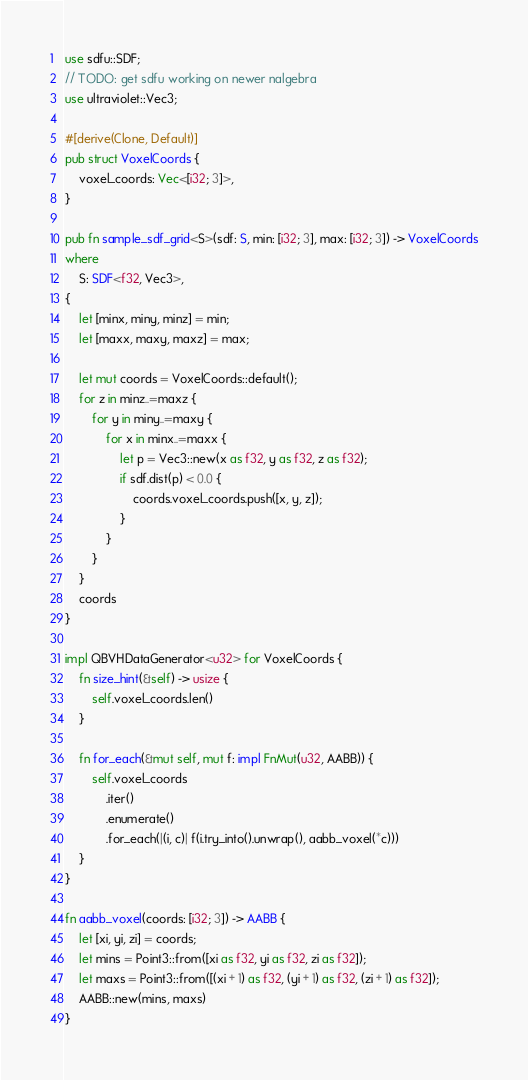<code> <loc_0><loc_0><loc_500><loc_500><_Rust_>use sdfu::SDF;
// TODO: get sdfu working on newer nalgebra
use ultraviolet::Vec3;

#[derive(Clone, Default)]
pub struct VoxelCoords {
    voxel_coords: Vec<[i32; 3]>,
}

pub fn sample_sdf_grid<S>(sdf: S, min: [i32; 3], max: [i32; 3]) -> VoxelCoords
where
    S: SDF<f32, Vec3>,
{
    let [minx, miny, minz] = min;
    let [maxx, maxy, maxz] = max;

    let mut coords = VoxelCoords::default();
    for z in minz..=maxz {
        for y in miny..=maxy {
            for x in minx..=maxx {
                let p = Vec3::new(x as f32, y as f32, z as f32);
                if sdf.dist(p) < 0.0 {
                    coords.voxel_coords.push([x, y, z]);
                }
            }
        }
    }
    coords
}

impl QBVHDataGenerator<u32> for VoxelCoords {
    fn size_hint(&self) -> usize {
        self.voxel_coords.len()
    }

    fn for_each(&mut self, mut f: impl FnMut(u32, AABB)) {
        self.voxel_coords
            .iter()
            .enumerate()
            .for_each(|(i, c)| f(i.try_into().unwrap(), aabb_voxel(*c)))
    }
}

fn aabb_voxel(coords: [i32; 3]) -> AABB {
    let [xi, yi, zi] = coords;
    let mins = Point3::from([xi as f32, yi as f32, zi as f32]);
    let maxs = Point3::from([(xi + 1) as f32, (yi + 1) as f32, (zi + 1) as f32]);
    AABB::new(mins, maxs)
}
</code> 